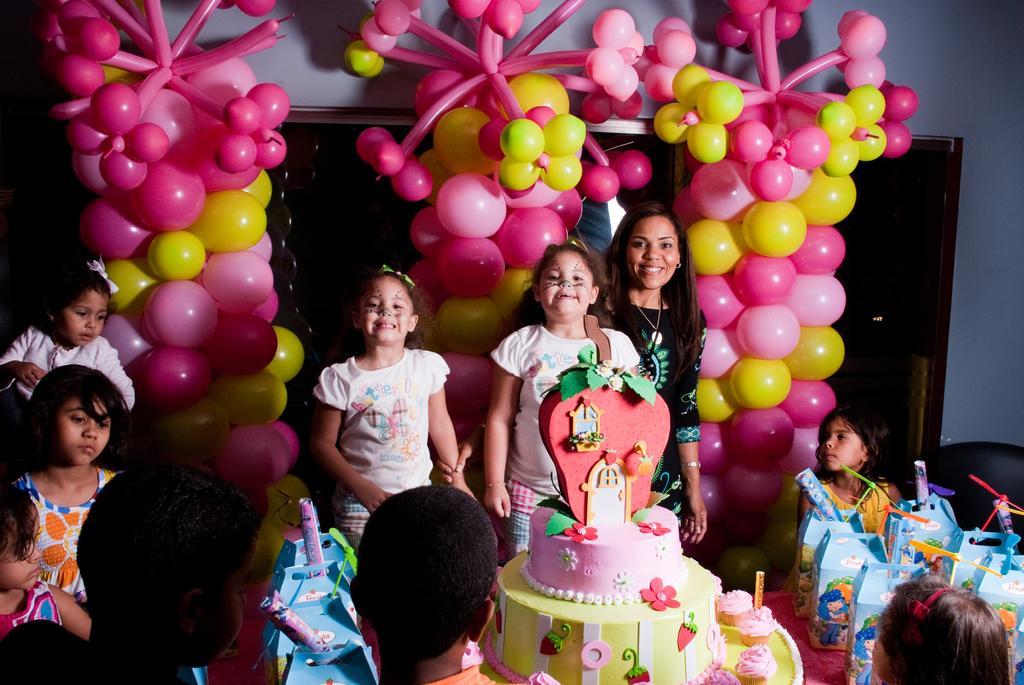Describe this image in one or two sentences. Here in this picture we can see a group of children and women present over a place and in the middle we can see a cake present and behind them we can see balloons decorated all over there and we can see all of them are smiling and we can also see some gift boxes present on the right side. 